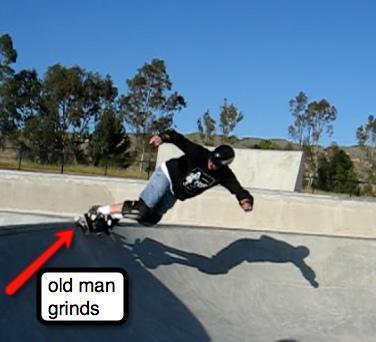How many people are in this photo?
Give a very brief answer. 1. How many people are in the photo?
Give a very brief answer. 1. 